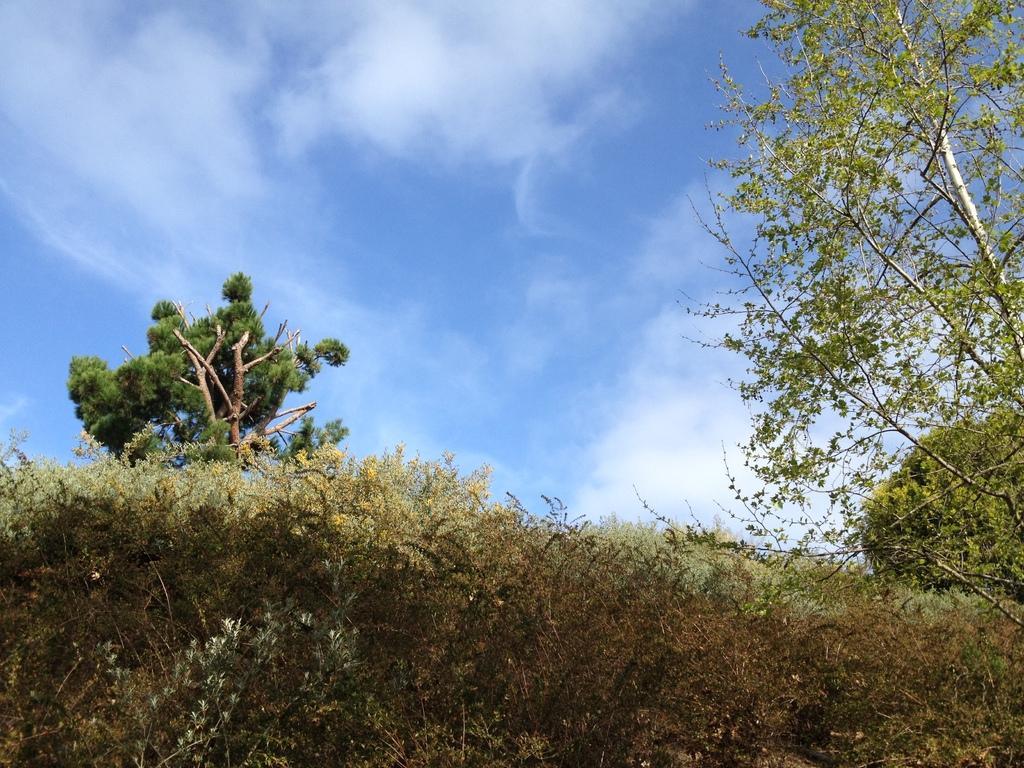Please provide a concise description of this image. In the image there are many plants and around the plants there are three trees. 